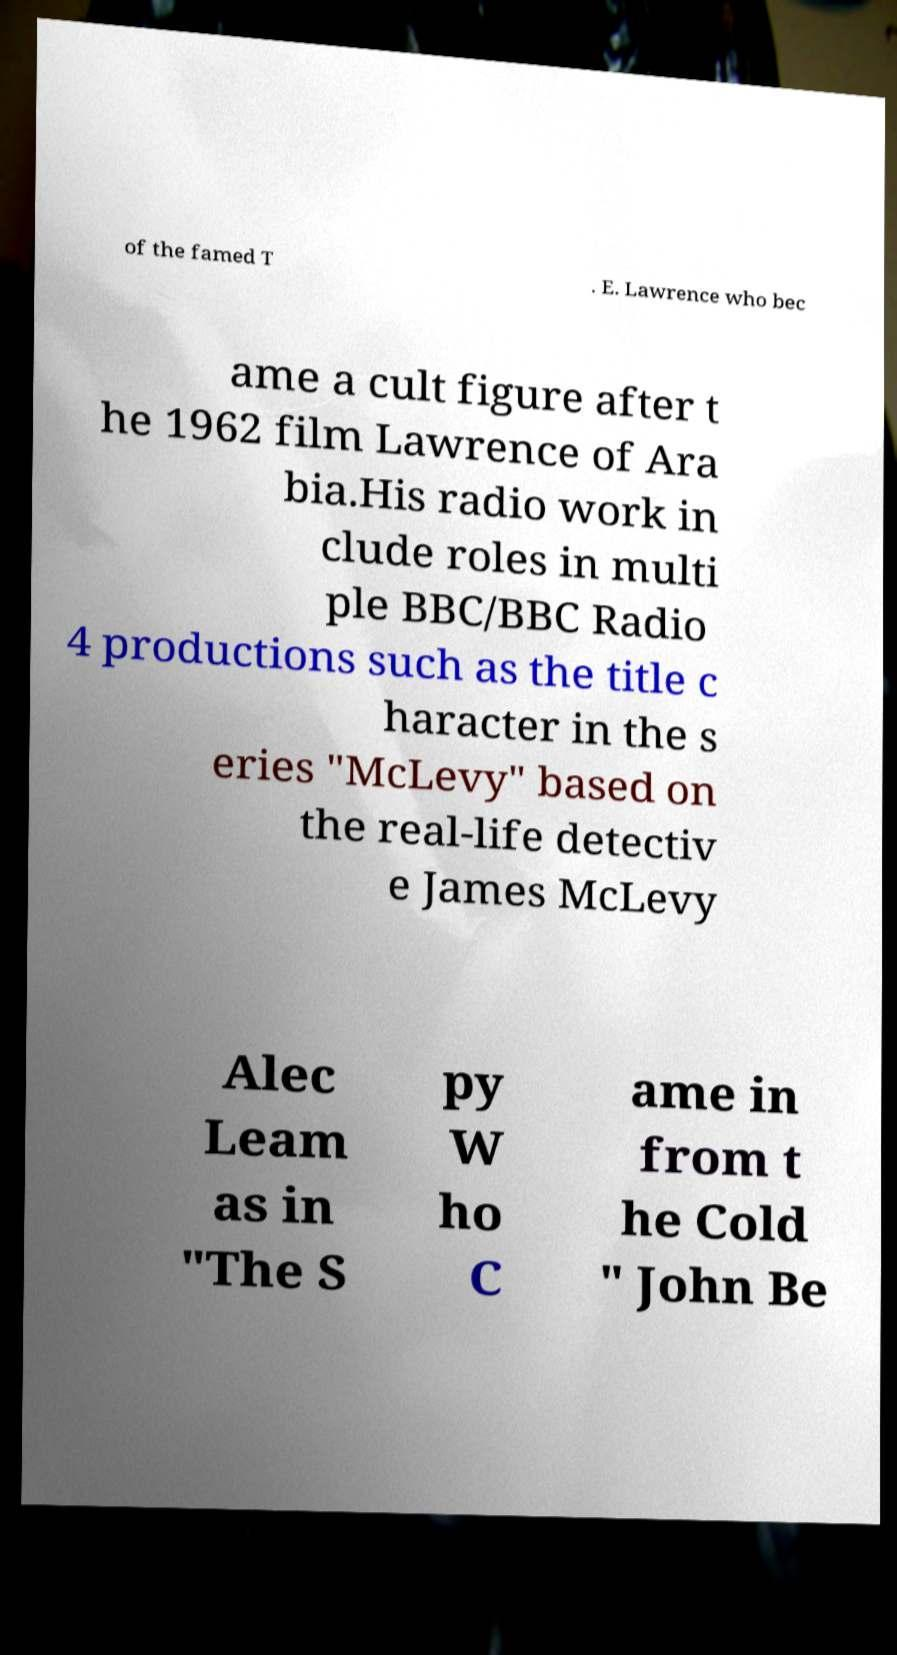Could you assist in decoding the text presented in this image and type it out clearly? of the famed T . E. Lawrence who bec ame a cult figure after t he 1962 film Lawrence of Ara bia.His radio work in clude roles in multi ple BBC/BBC Radio 4 productions such as the title c haracter in the s eries "McLevy" based on the real-life detectiv e James McLevy Alec Leam as in "The S py W ho C ame in from t he Cold " John Be 